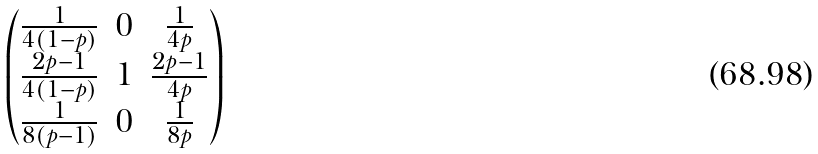<formula> <loc_0><loc_0><loc_500><loc_500>\begin{pmatrix} \frac { 1 } { 4 ( 1 - p ) } & 0 & \frac { 1 } { 4 p } \\ \frac { 2 p - 1 } { 4 ( 1 - p ) } & 1 & \frac { 2 p - 1 } { 4 p } \\ \frac { 1 } { 8 ( p - 1 ) } & 0 & \frac { 1 } { 8 p } \end{pmatrix}</formula> 